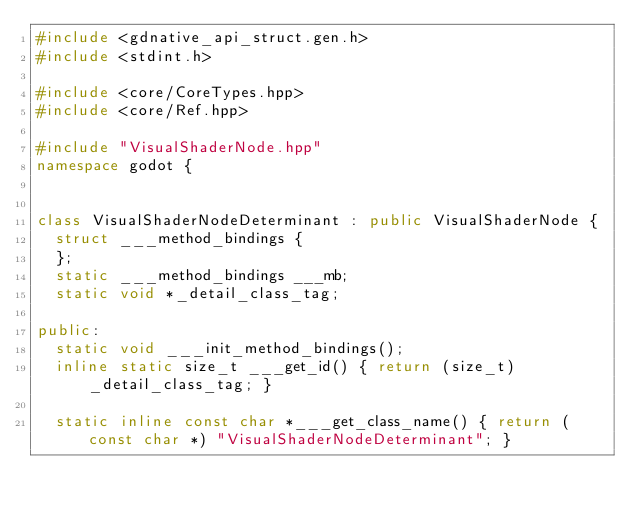Convert code to text. <code><loc_0><loc_0><loc_500><loc_500><_C++_>#include <gdnative_api_struct.gen.h>
#include <stdint.h>

#include <core/CoreTypes.hpp>
#include <core/Ref.hpp>

#include "VisualShaderNode.hpp"
namespace godot {


class VisualShaderNodeDeterminant : public VisualShaderNode {
	struct ___method_bindings {
	};
	static ___method_bindings ___mb;
	static void *_detail_class_tag;

public:
	static void ___init_method_bindings();
	inline static size_t ___get_id() { return (size_t)_detail_class_tag; }

	static inline const char *___get_class_name() { return (const char *) "VisualShaderNodeDeterminant"; }</code> 